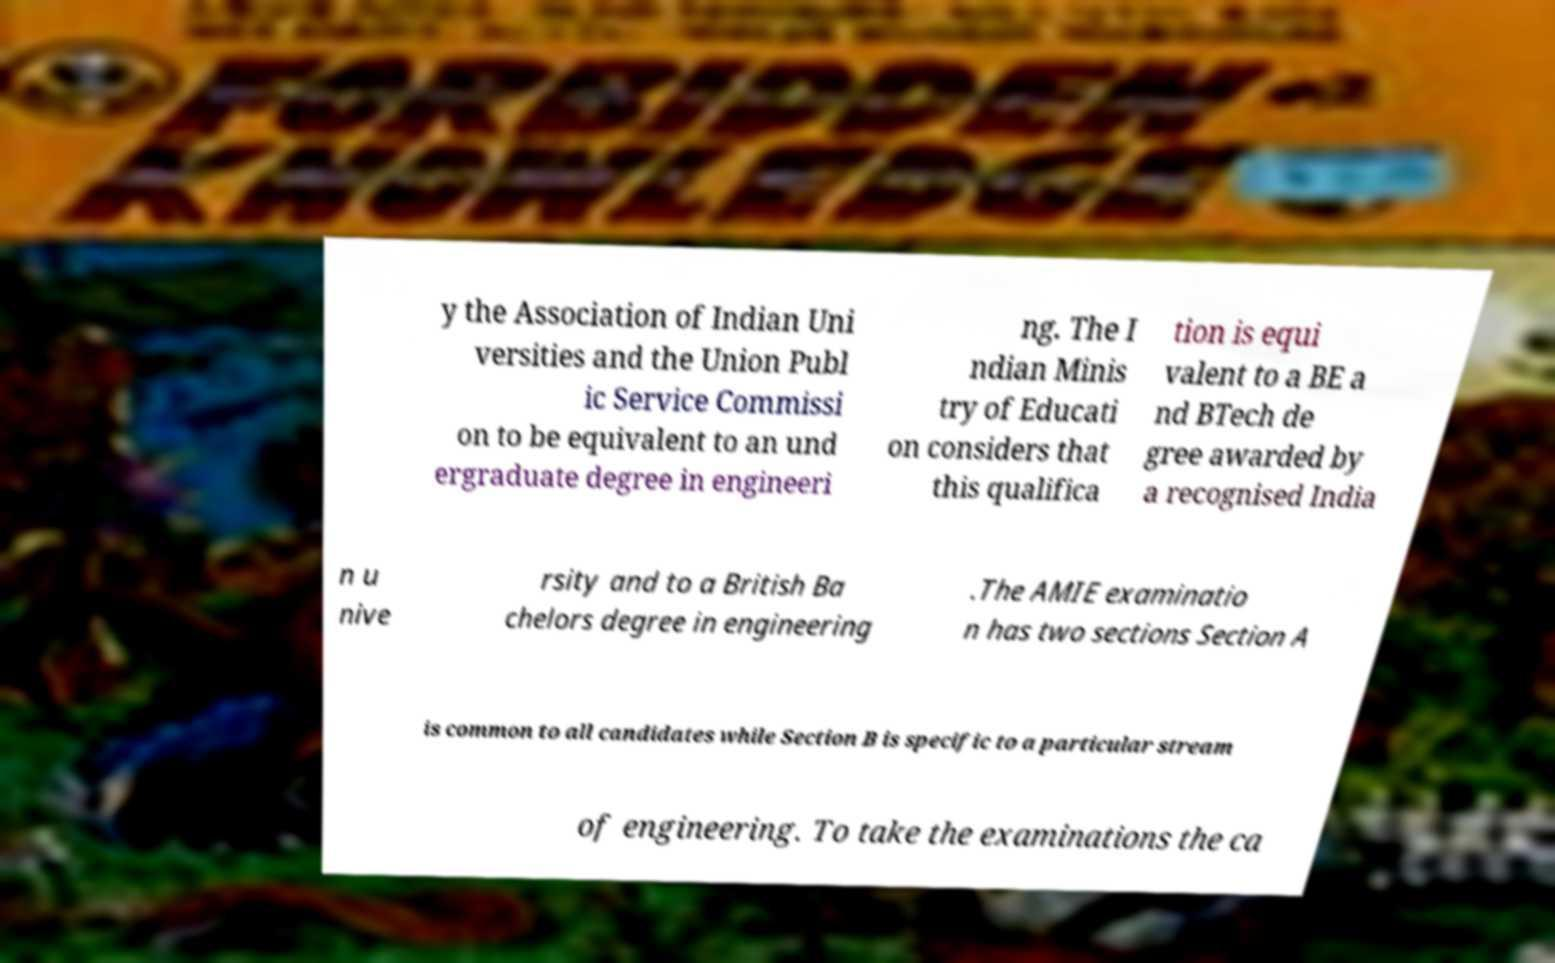There's text embedded in this image that I need extracted. Can you transcribe it verbatim? y the Association of Indian Uni versities and the Union Publ ic Service Commissi on to be equivalent to an und ergraduate degree in engineeri ng. The I ndian Minis try of Educati on considers that this qualifica tion is equi valent to a BE a nd BTech de gree awarded by a recognised India n u nive rsity and to a British Ba chelors degree in engineering .The AMIE examinatio n has two sections Section A is common to all candidates while Section B is specific to a particular stream of engineering. To take the examinations the ca 